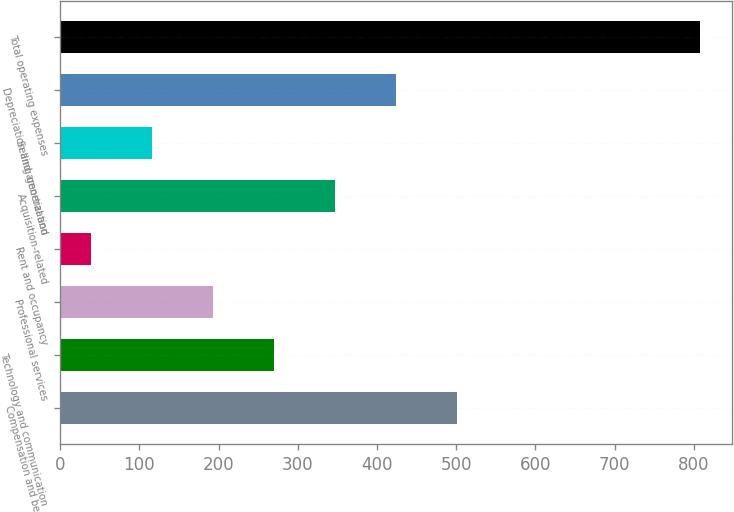<chart> <loc_0><loc_0><loc_500><loc_500><bar_chart><fcel>Compensation and benefits<fcel>Technology and communication<fcel>Professional services<fcel>Rent and occupancy<fcel>Acquisition-related<fcel>Selling general and<fcel>Depreciation and amortization<fcel>Total operating expenses<nl><fcel>500.4<fcel>269.7<fcel>192.8<fcel>39<fcel>346.6<fcel>115.9<fcel>423.5<fcel>808<nl></chart> 